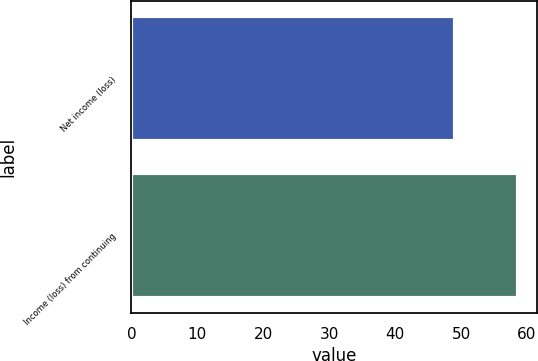Convert chart to OTSL. <chart><loc_0><loc_0><loc_500><loc_500><bar_chart><fcel>Net income (loss)<fcel>Income (loss) from continuing<nl><fcel>49.1<fcel>58.6<nl></chart> 